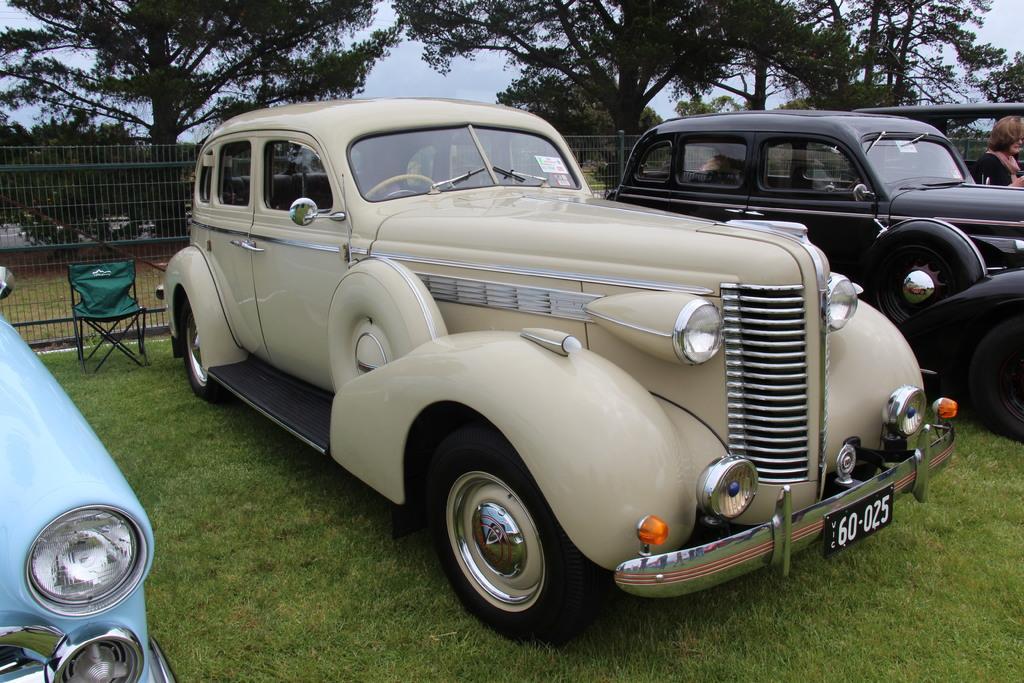Could you give a brief overview of what you see in this image? At the bottom of the image I can see the grass. In the middle of the image I can see vehicles and the chair. In the background, I can see grills and a group of trees. There is a sky on the top of this image. 